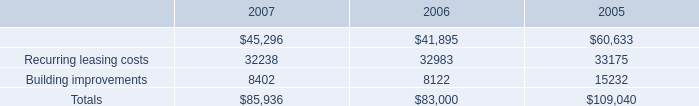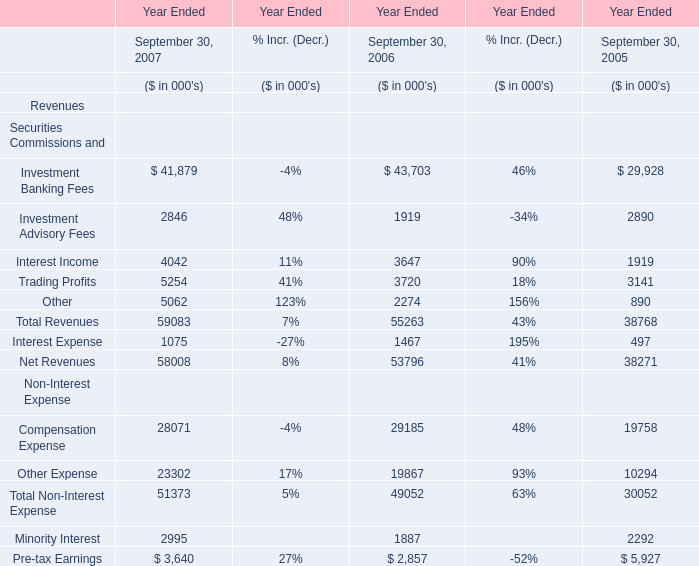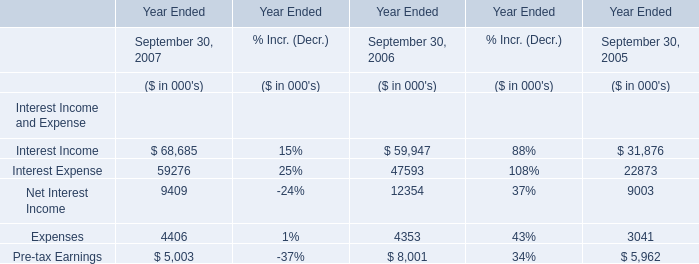What was the average value of the Net Interest Income in the years where Interest Income is positive? (in million) 
Computations: (((9409 + 12354) + 9003) / 3)
Answer: 10255.33333. 